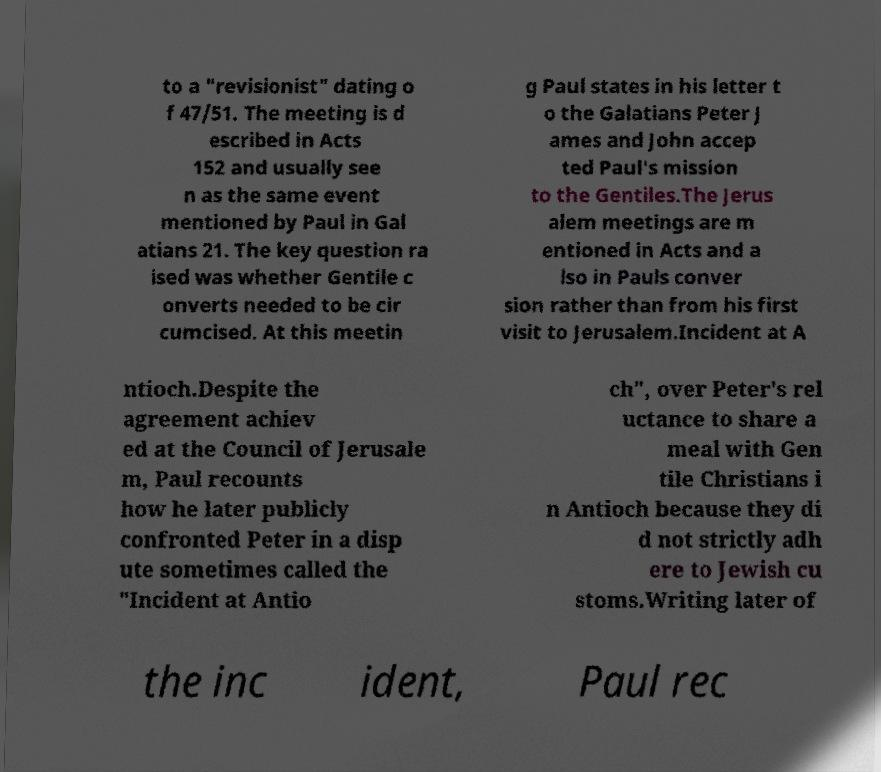For documentation purposes, I need the text within this image transcribed. Could you provide that? to a "revisionist" dating o f 47/51. The meeting is d escribed in Acts 152 and usually see n as the same event mentioned by Paul in Gal atians 21. The key question ra ised was whether Gentile c onverts needed to be cir cumcised. At this meetin g Paul states in his letter t o the Galatians Peter J ames and John accep ted Paul's mission to the Gentiles.The Jerus alem meetings are m entioned in Acts and a lso in Pauls conver sion rather than from his first visit to Jerusalem.Incident at A ntioch.Despite the agreement achiev ed at the Council of Jerusale m, Paul recounts how he later publicly confronted Peter in a disp ute sometimes called the "Incident at Antio ch", over Peter's rel uctance to share a meal with Gen tile Christians i n Antioch because they di d not strictly adh ere to Jewish cu stoms.Writing later of the inc ident, Paul rec 